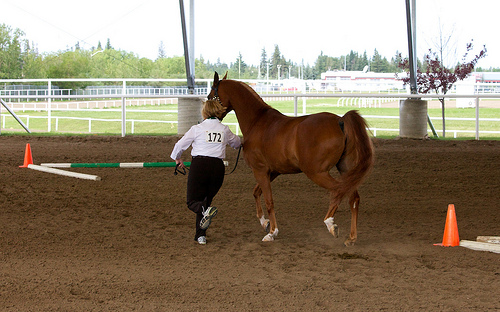<image>
Can you confirm if the man is on the horse? No. The man is not positioned on the horse. They may be near each other, but the man is not supported by or resting on top of the horse. 